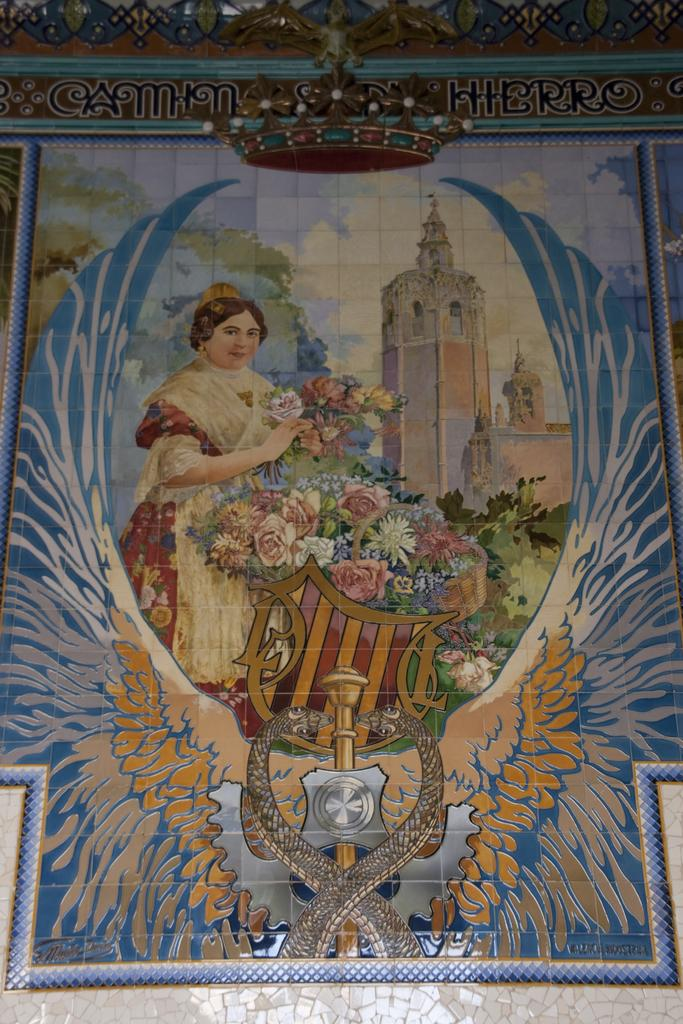What is the main subject of the image? There is a picture of a woman in the image. What can be seen behind the picture of the woman? The picture of the woman is on a tiled surface. What type of rhythm does the woman in the picture have? There is no indication of rhythm in the image, as it only features a picture of a woman on a tiled surface. 